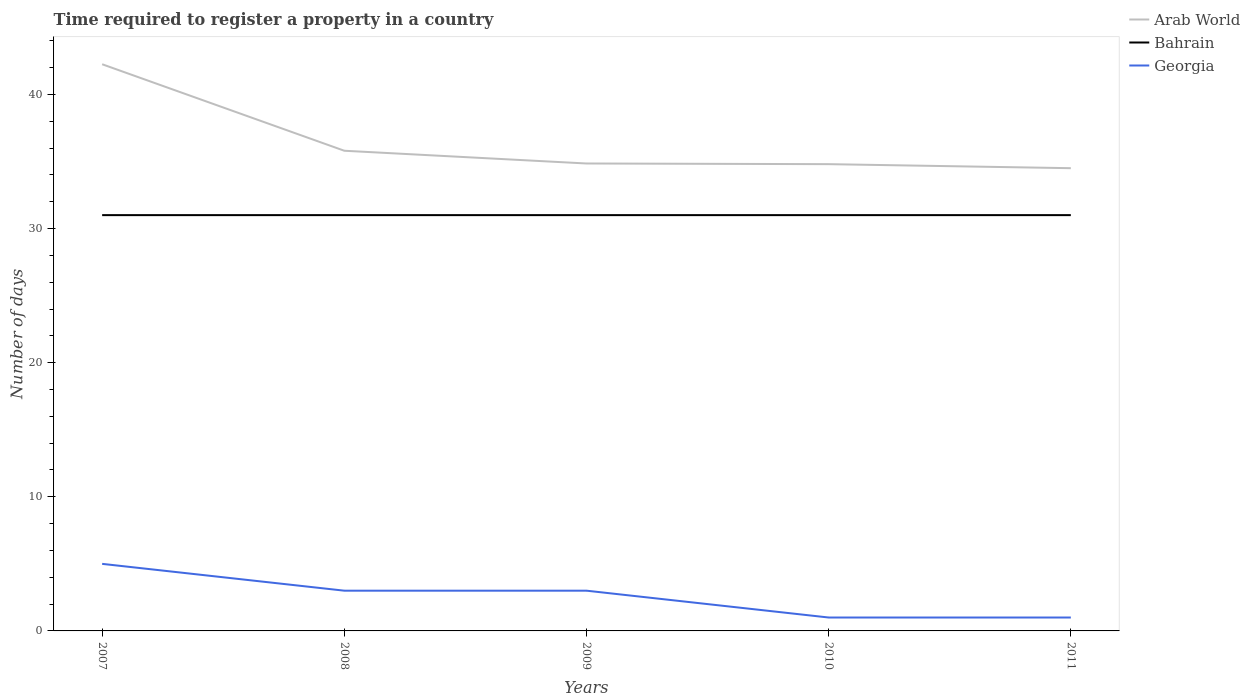How many different coloured lines are there?
Your response must be concise. 3. Across all years, what is the maximum number of days required to register a property in Georgia?
Provide a succinct answer. 1. What is the total number of days required to register a property in Georgia in the graph?
Make the answer very short. 2. What is the difference between the highest and the second highest number of days required to register a property in Bahrain?
Offer a very short reply. 0. Is the number of days required to register a property in Georgia strictly greater than the number of days required to register a property in Arab World over the years?
Ensure brevity in your answer.  Yes. How many years are there in the graph?
Provide a succinct answer. 5. What is the difference between two consecutive major ticks on the Y-axis?
Your answer should be compact. 10. How many legend labels are there?
Your answer should be very brief. 3. What is the title of the graph?
Your response must be concise. Time required to register a property in a country. What is the label or title of the X-axis?
Provide a short and direct response. Years. What is the label or title of the Y-axis?
Your answer should be very brief. Number of days. What is the Number of days in Arab World in 2007?
Ensure brevity in your answer.  42.25. What is the Number of days of Arab World in 2008?
Keep it short and to the point. 35.8. What is the Number of days in Arab World in 2009?
Make the answer very short. 34.85. What is the Number of days in Bahrain in 2009?
Your answer should be compact. 31. What is the Number of days of Georgia in 2009?
Offer a terse response. 3. What is the Number of days of Arab World in 2010?
Give a very brief answer. 34.8. What is the Number of days of Georgia in 2010?
Offer a very short reply. 1. What is the Number of days of Arab World in 2011?
Your answer should be very brief. 34.5. What is the Number of days in Georgia in 2011?
Provide a short and direct response. 1. Across all years, what is the maximum Number of days of Arab World?
Give a very brief answer. 42.25. Across all years, what is the maximum Number of days of Bahrain?
Make the answer very short. 31. Across all years, what is the minimum Number of days of Arab World?
Your answer should be compact. 34.5. Across all years, what is the minimum Number of days in Georgia?
Your answer should be very brief. 1. What is the total Number of days in Arab World in the graph?
Give a very brief answer. 182.2. What is the total Number of days in Bahrain in the graph?
Make the answer very short. 155. What is the difference between the Number of days of Arab World in 2007 and that in 2008?
Make the answer very short. 6.45. What is the difference between the Number of days in Bahrain in 2007 and that in 2009?
Give a very brief answer. 0. What is the difference between the Number of days of Georgia in 2007 and that in 2009?
Make the answer very short. 2. What is the difference between the Number of days in Arab World in 2007 and that in 2010?
Offer a very short reply. 7.45. What is the difference between the Number of days of Georgia in 2007 and that in 2010?
Provide a short and direct response. 4. What is the difference between the Number of days of Arab World in 2007 and that in 2011?
Your answer should be very brief. 7.75. What is the difference between the Number of days of Bahrain in 2007 and that in 2011?
Provide a succinct answer. 0. What is the difference between the Number of days of Bahrain in 2008 and that in 2010?
Give a very brief answer. 0. What is the difference between the Number of days of Georgia in 2008 and that in 2010?
Your answer should be very brief. 2. What is the difference between the Number of days in Bahrain in 2008 and that in 2011?
Your answer should be compact. 0. What is the difference between the Number of days of Georgia in 2008 and that in 2011?
Give a very brief answer. 2. What is the difference between the Number of days in Bahrain in 2009 and that in 2010?
Your response must be concise. 0. What is the difference between the Number of days of Arab World in 2009 and that in 2011?
Keep it short and to the point. 0.35. What is the difference between the Number of days of Bahrain in 2009 and that in 2011?
Make the answer very short. 0. What is the difference between the Number of days in Arab World in 2010 and that in 2011?
Offer a very short reply. 0.3. What is the difference between the Number of days in Arab World in 2007 and the Number of days in Bahrain in 2008?
Make the answer very short. 11.25. What is the difference between the Number of days of Arab World in 2007 and the Number of days of Georgia in 2008?
Make the answer very short. 39.25. What is the difference between the Number of days of Arab World in 2007 and the Number of days of Bahrain in 2009?
Provide a succinct answer. 11.25. What is the difference between the Number of days in Arab World in 2007 and the Number of days in Georgia in 2009?
Your response must be concise. 39.25. What is the difference between the Number of days of Bahrain in 2007 and the Number of days of Georgia in 2009?
Provide a short and direct response. 28. What is the difference between the Number of days in Arab World in 2007 and the Number of days in Bahrain in 2010?
Ensure brevity in your answer.  11.25. What is the difference between the Number of days of Arab World in 2007 and the Number of days of Georgia in 2010?
Keep it short and to the point. 41.25. What is the difference between the Number of days of Arab World in 2007 and the Number of days of Bahrain in 2011?
Provide a short and direct response. 11.25. What is the difference between the Number of days of Arab World in 2007 and the Number of days of Georgia in 2011?
Your answer should be very brief. 41.25. What is the difference between the Number of days of Arab World in 2008 and the Number of days of Bahrain in 2009?
Ensure brevity in your answer.  4.8. What is the difference between the Number of days of Arab World in 2008 and the Number of days of Georgia in 2009?
Make the answer very short. 32.8. What is the difference between the Number of days in Bahrain in 2008 and the Number of days in Georgia in 2009?
Your answer should be compact. 28. What is the difference between the Number of days in Arab World in 2008 and the Number of days in Bahrain in 2010?
Your answer should be very brief. 4.8. What is the difference between the Number of days in Arab World in 2008 and the Number of days in Georgia in 2010?
Provide a succinct answer. 34.8. What is the difference between the Number of days of Arab World in 2008 and the Number of days of Bahrain in 2011?
Keep it short and to the point. 4.8. What is the difference between the Number of days of Arab World in 2008 and the Number of days of Georgia in 2011?
Your answer should be compact. 34.8. What is the difference between the Number of days of Bahrain in 2008 and the Number of days of Georgia in 2011?
Give a very brief answer. 30. What is the difference between the Number of days of Arab World in 2009 and the Number of days of Bahrain in 2010?
Keep it short and to the point. 3.85. What is the difference between the Number of days of Arab World in 2009 and the Number of days of Georgia in 2010?
Make the answer very short. 33.85. What is the difference between the Number of days of Arab World in 2009 and the Number of days of Bahrain in 2011?
Provide a short and direct response. 3.85. What is the difference between the Number of days in Arab World in 2009 and the Number of days in Georgia in 2011?
Give a very brief answer. 33.85. What is the difference between the Number of days in Arab World in 2010 and the Number of days in Georgia in 2011?
Offer a very short reply. 33.8. What is the average Number of days of Arab World per year?
Provide a short and direct response. 36.44. What is the average Number of days of Georgia per year?
Keep it short and to the point. 2.6. In the year 2007, what is the difference between the Number of days of Arab World and Number of days of Bahrain?
Provide a short and direct response. 11.25. In the year 2007, what is the difference between the Number of days of Arab World and Number of days of Georgia?
Give a very brief answer. 37.25. In the year 2008, what is the difference between the Number of days of Arab World and Number of days of Georgia?
Give a very brief answer. 32.8. In the year 2008, what is the difference between the Number of days of Bahrain and Number of days of Georgia?
Your answer should be compact. 28. In the year 2009, what is the difference between the Number of days in Arab World and Number of days in Bahrain?
Offer a terse response. 3.85. In the year 2009, what is the difference between the Number of days in Arab World and Number of days in Georgia?
Your answer should be very brief. 31.85. In the year 2009, what is the difference between the Number of days in Bahrain and Number of days in Georgia?
Ensure brevity in your answer.  28. In the year 2010, what is the difference between the Number of days in Arab World and Number of days in Bahrain?
Give a very brief answer. 3.8. In the year 2010, what is the difference between the Number of days in Arab World and Number of days in Georgia?
Your response must be concise. 33.8. In the year 2010, what is the difference between the Number of days of Bahrain and Number of days of Georgia?
Provide a succinct answer. 30. In the year 2011, what is the difference between the Number of days in Arab World and Number of days in Bahrain?
Make the answer very short. 3.5. In the year 2011, what is the difference between the Number of days of Arab World and Number of days of Georgia?
Your answer should be compact. 33.5. What is the ratio of the Number of days of Arab World in 2007 to that in 2008?
Keep it short and to the point. 1.18. What is the ratio of the Number of days in Bahrain in 2007 to that in 2008?
Your answer should be compact. 1. What is the ratio of the Number of days in Arab World in 2007 to that in 2009?
Provide a short and direct response. 1.21. What is the ratio of the Number of days of Arab World in 2007 to that in 2010?
Ensure brevity in your answer.  1.21. What is the ratio of the Number of days of Bahrain in 2007 to that in 2010?
Keep it short and to the point. 1. What is the ratio of the Number of days in Georgia in 2007 to that in 2010?
Give a very brief answer. 5. What is the ratio of the Number of days in Arab World in 2007 to that in 2011?
Your answer should be compact. 1.22. What is the ratio of the Number of days in Arab World in 2008 to that in 2009?
Make the answer very short. 1.03. What is the ratio of the Number of days of Georgia in 2008 to that in 2009?
Provide a short and direct response. 1. What is the ratio of the Number of days in Arab World in 2008 to that in 2010?
Provide a succinct answer. 1.03. What is the ratio of the Number of days in Georgia in 2008 to that in 2010?
Ensure brevity in your answer.  3. What is the ratio of the Number of days in Arab World in 2008 to that in 2011?
Your answer should be very brief. 1.04. What is the ratio of the Number of days of Bahrain in 2008 to that in 2011?
Keep it short and to the point. 1. What is the ratio of the Number of days of Georgia in 2008 to that in 2011?
Keep it short and to the point. 3. What is the ratio of the Number of days in Arab World in 2009 to that in 2010?
Give a very brief answer. 1. What is the ratio of the Number of days in Arab World in 2009 to that in 2011?
Your response must be concise. 1.01. What is the ratio of the Number of days of Bahrain in 2009 to that in 2011?
Your answer should be very brief. 1. What is the ratio of the Number of days in Georgia in 2009 to that in 2011?
Provide a succinct answer. 3. What is the ratio of the Number of days in Arab World in 2010 to that in 2011?
Make the answer very short. 1.01. What is the difference between the highest and the second highest Number of days in Arab World?
Your answer should be very brief. 6.45. What is the difference between the highest and the second highest Number of days in Georgia?
Provide a short and direct response. 2. What is the difference between the highest and the lowest Number of days of Arab World?
Give a very brief answer. 7.75. What is the difference between the highest and the lowest Number of days in Bahrain?
Ensure brevity in your answer.  0. What is the difference between the highest and the lowest Number of days in Georgia?
Give a very brief answer. 4. 